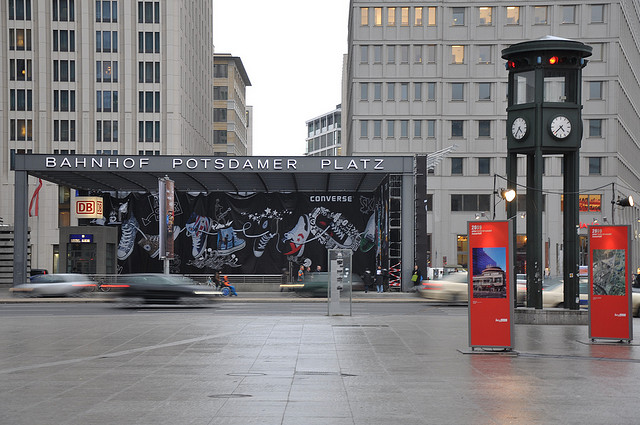Please extract the text content from this image. BAHNH OF POTS DAMER PLATZ CONVERSE DB 